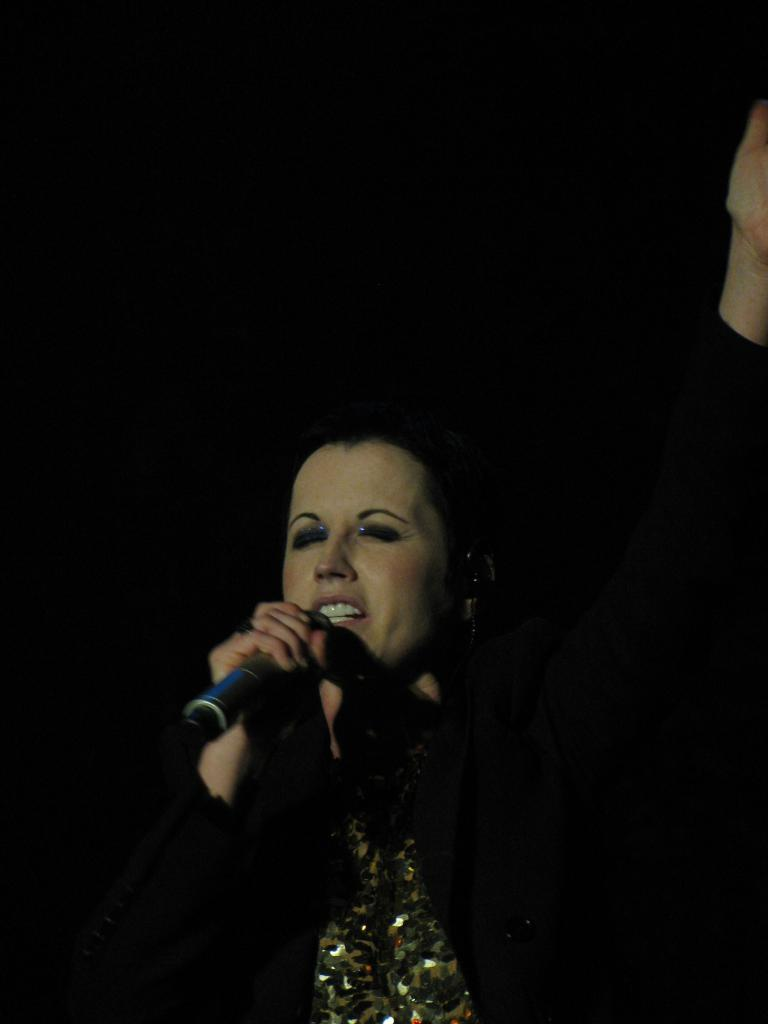What is the main subject of the image? There is a person in the image. What is the person holding in the image? The person is holding a mic. What type of sponge can be seen in the image? There is no sponge present in the image. How many houses are visible in the image? There are no houses visible in the image. What type of vacation is the person in the image planning? There is no indication in the image that the person is planning a vacation. 